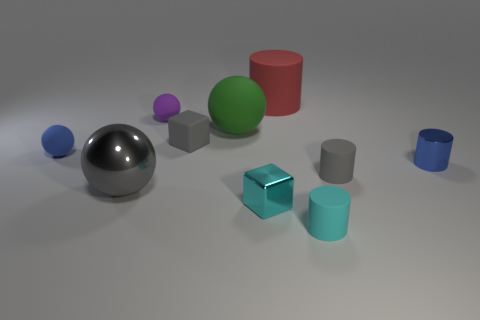Do the big metallic thing and the small matte block have the same color?
Provide a short and direct response. Yes. The gray shiny object is what size?
Your response must be concise. Large. There is a matte cylinder that is behind the small cube that is on the left side of the big rubber object left of the tiny cyan shiny thing; what is its color?
Your answer should be compact. Red. Do the small sphere that is in front of the rubber block and the metal cylinder have the same color?
Make the answer very short. Yes. What number of objects are both behind the large gray thing and on the right side of the tiny purple matte thing?
Ensure brevity in your answer.  5. The gray rubber object that is the same shape as the small cyan metal object is what size?
Keep it short and to the point. Small. What number of small cubes are on the left side of the small blue object left of the small shiny thing that is behind the gray metal thing?
Make the answer very short. 0. There is a large thing that is in front of the small gray matte object to the right of the red rubber thing; what color is it?
Offer a terse response. Gray. How many other things are made of the same material as the tiny blue cylinder?
Make the answer very short. 2. There is a small cyan thing in front of the tiny cyan metal cube; what number of matte things are on the left side of it?
Give a very brief answer. 5. 